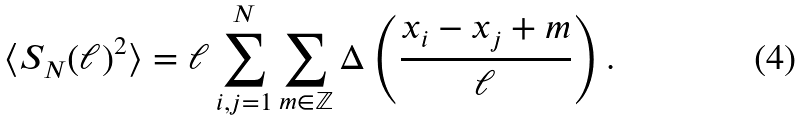Convert formula to latex. <formula><loc_0><loc_0><loc_500><loc_500>\langle S _ { N } ( \ell ) ^ { 2 } \rangle = \ell \sum _ { i , j = 1 } ^ { N } \sum _ { m \in \mathbb { Z } } \Delta \left ( \frac { x _ { i } - x _ { j } + m } { \ell } \right ) .</formula> 